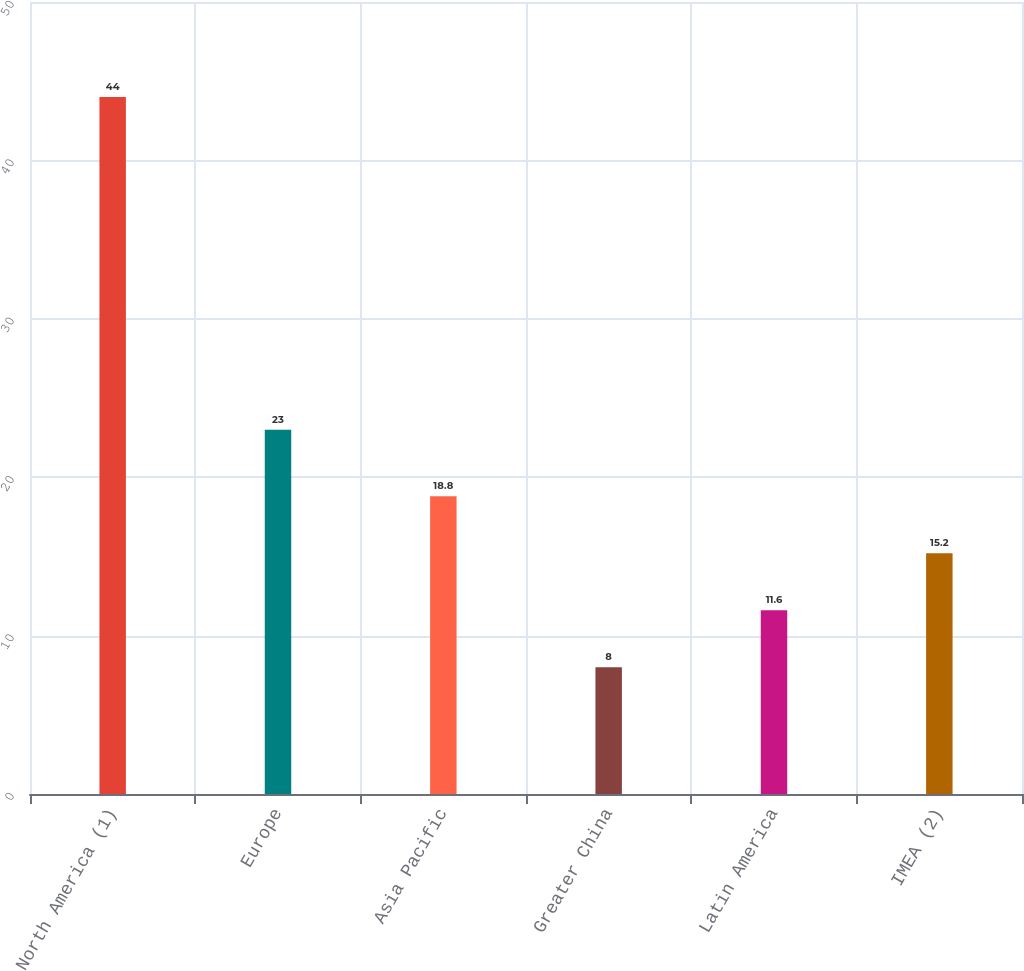Convert chart to OTSL. <chart><loc_0><loc_0><loc_500><loc_500><bar_chart><fcel>North America (1)<fcel>Europe<fcel>Asia Pacific<fcel>Greater China<fcel>Latin America<fcel>IMEA (2)<nl><fcel>44<fcel>23<fcel>18.8<fcel>8<fcel>11.6<fcel>15.2<nl></chart> 